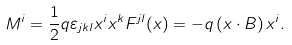Convert formula to latex. <formula><loc_0><loc_0><loc_500><loc_500>M ^ { i } = \frac { 1 } { 2 } q \varepsilon _ { j k l } x ^ { i } x ^ { k } F ^ { j l } ( x ) = - q \left ( x \cdot B \right ) x ^ { i } .</formula> 